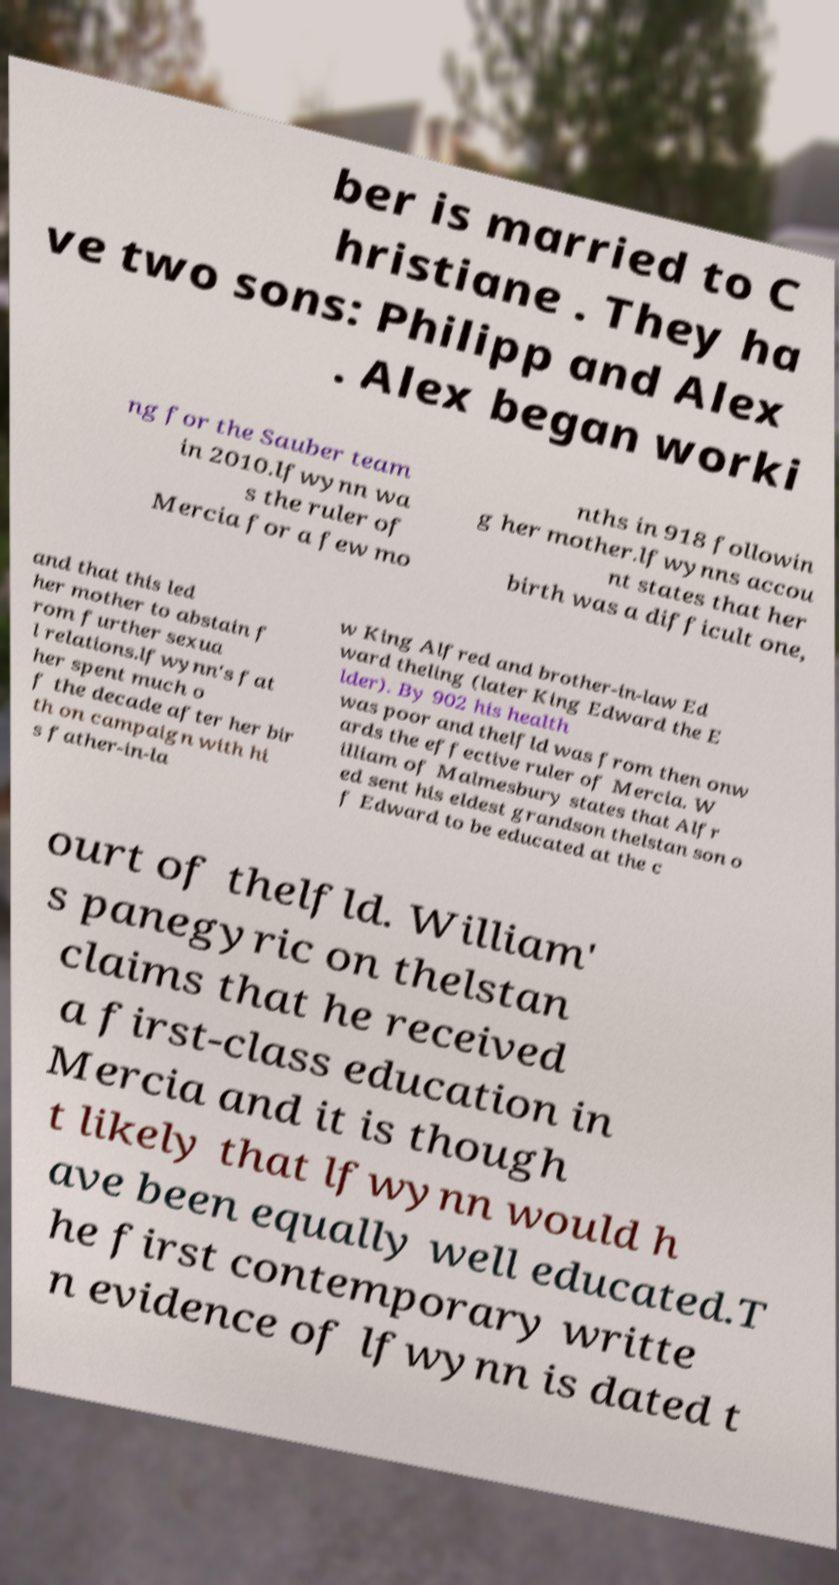Please identify and transcribe the text found in this image. ber is married to C hristiane . They ha ve two sons: Philipp and Alex . Alex began worki ng for the Sauber team in 2010.lfwynn wa s the ruler of Mercia for a few mo nths in 918 followin g her mother.lfwynns accou nt states that her birth was a difficult one, and that this led her mother to abstain f rom further sexua l relations.lfwynn's fat her spent much o f the decade after her bir th on campaign with hi s father-in-la w King Alfred and brother-in-law Ed ward theling (later King Edward the E lder). By 902 his health was poor and thelfld was from then onw ards the effective ruler of Mercia. W illiam of Malmesbury states that Alfr ed sent his eldest grandson thelstan son o f Edward to be educated at the c ourt of thelfld. William' s panegyric on thelstan claims that he received a first-class education in Mercia and it is though t likely that lfwynn would h ave been equally well educated.T he first contemporary writte n evidence of lfwynn is dated t 